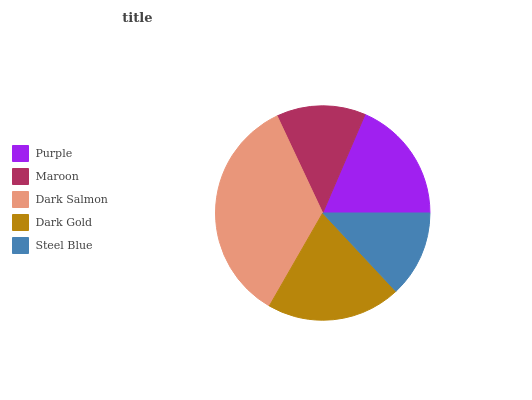Is Steel Blue the minimum?
Answer yes or no. Yes. Is Dark Salmon the maximum?
Answer yes or no. Yes. Is Maroon the minimum?
Answer yes or no. No. Is Maroon the maximum?
Answer yes or no. No. Is Purple greater than Maroon?
Answer yes or no. Yes. Is Maroon less than Purple?
Answer yes or no. Yes. Is Maroon greater than Purple?
Answer yes or no. No. Is Purple less than Maroon?
Answer yes or no. No. Is Purple the high median?
Answer yes or no. Yes. Is Purple the low median?
Answer yes or no. Yes. Is Steel Blue the high median?
Answer yes or no. No. Is Dark Salmon the low median?
Answer yes or no. No. 